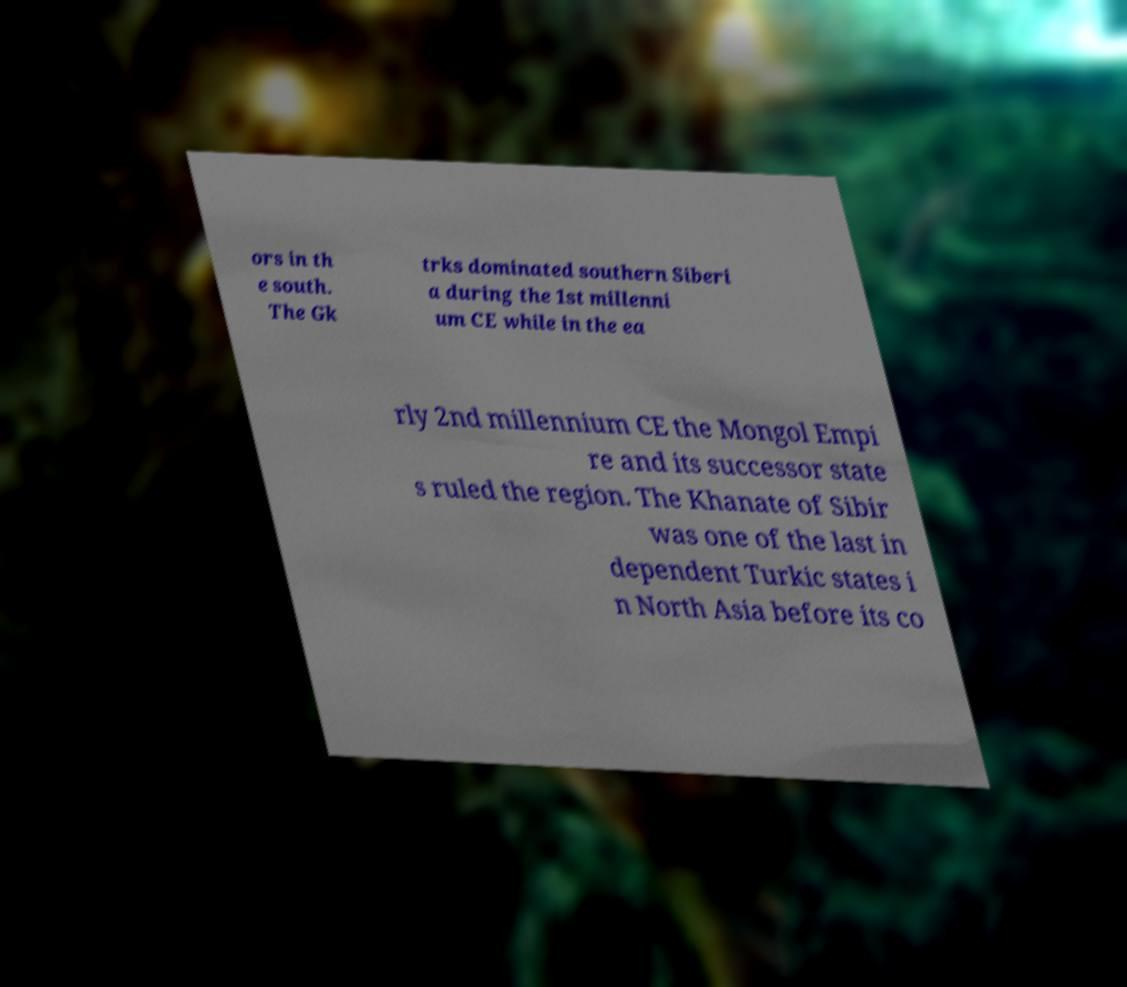What messages or text are displayed in this image? I need them in a readable, typed format. ors in th e south. The Gk trks dominated southern Siberi a during the 1st millenni um CE while in the ea rly 2nd millennium CE the Mongol Empi re and its successor state s ruled the region. The Khanate of Sibir was one of the last in dependent Turkic states i n North Asia before its co 